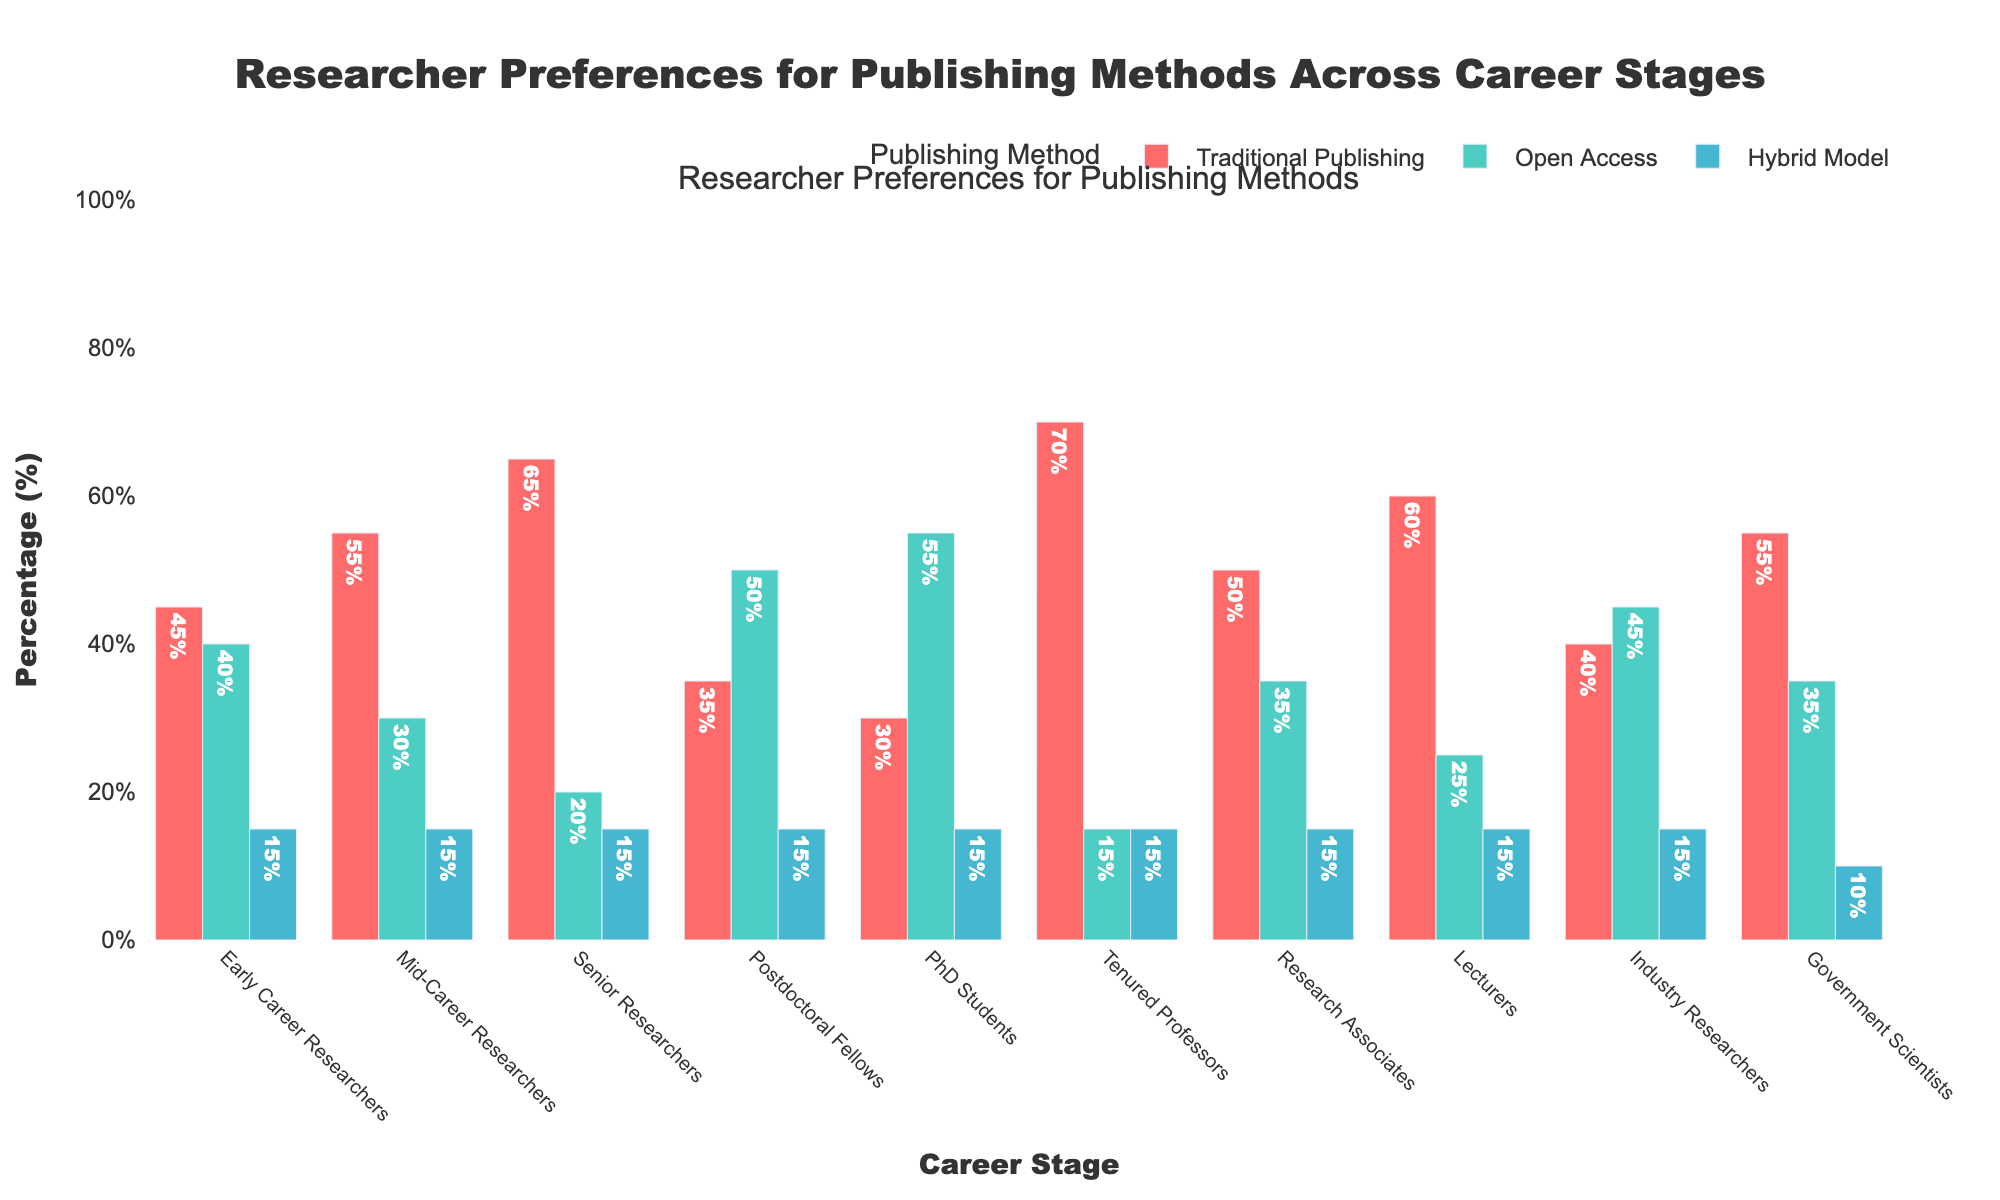What is the percentage preference for Open Access among Early Career Researchers? Refer to the bar representing Early Career Researchers under Open Access; the label reads 40%.
Answer: 40% Which career stage shows the highest preference for Traditional Publishing? Compare the heights of the bars for Traditional Publishing across all career stages; Tenured Professors prefer it the most with 70%.
Answer: Tenured Professors How much higher is the preference for Traditional Publishing among Senior Researchers than Mid-Career Researchers? Mid-Career Researchers have a 55% preference for Traditional Publishing while Senior Researchers have 65%; the difference is 65% - 55% = 10%.
Answer: 10% What is the combined percentage preference for the Hybrid Model across all career stages? Add up the percentages for Hybrid Model for each career stage: (15+15+15+15+15+15+15+15+15+10) = 145%.
Answer: 145% Which career stage favors Open Access more than Traditional Publishing? Compare the heights of the bars for Open Access and Traditional Publishing for each career stage; Postdoctoral Fellows and PhD Students prefer Open Access more.
Answer: Postdoctoral Fellows and PhD Students What is the average preference percentage for Open Access across all career stages? Add Open Access percentages: (40+30+20+50+55+15+35+25+45+35) = 350, then divide by the number of career stages: 350 / 10 = 35%.
Answer: 35% In which two career stages is the preference for Hybrid Model equal? Identify the bars for the Hybrid Model which have the same height; all but Government Scientists, who have a lower 10%, have equal preference of 15%.
Answer: All except Government Scientists Is there any career stage where Open Access is preferred over all other models? Compare the height of the Open Access bar with the bars of other models for each career stage; Postdoctoral Fellows and PhD Students prefer Open Access the most.
Answer: Postdoctoral Fellows and PhD Students How does the preference for Open Access among Industry Researchers compare with that among Government Scientists? Industry Researchers prefer Open Access with 45% while Government Scientists have 35%; hence, Industry Researchers have a higher preference.
Answer: Industry Researchers What is the total percentage preference for Traditional Publishing among Academics (Early Career, Mid-Career, Senior, and Tenured Professors)? Add percentages: (45+55+65+70) = 235%.
Answer: 235% 